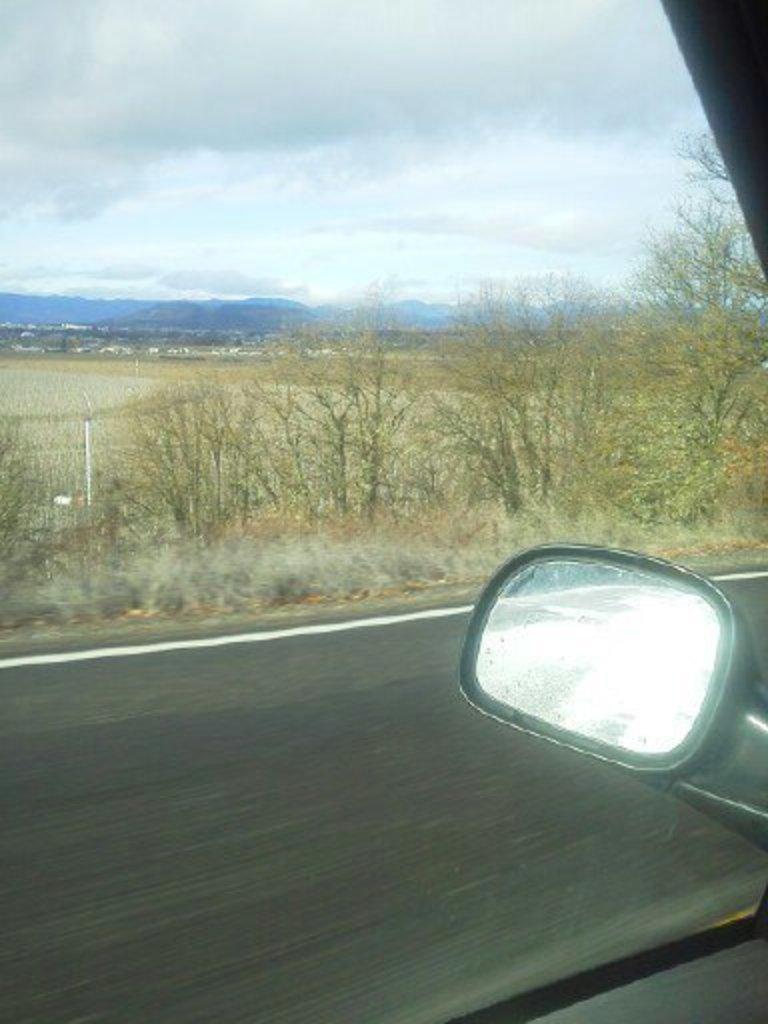Can you describe this image briefly? In this image we can see the vehicle glass window through which we can see the mirror, road, trees, hills and the sky with clouds in the background. 